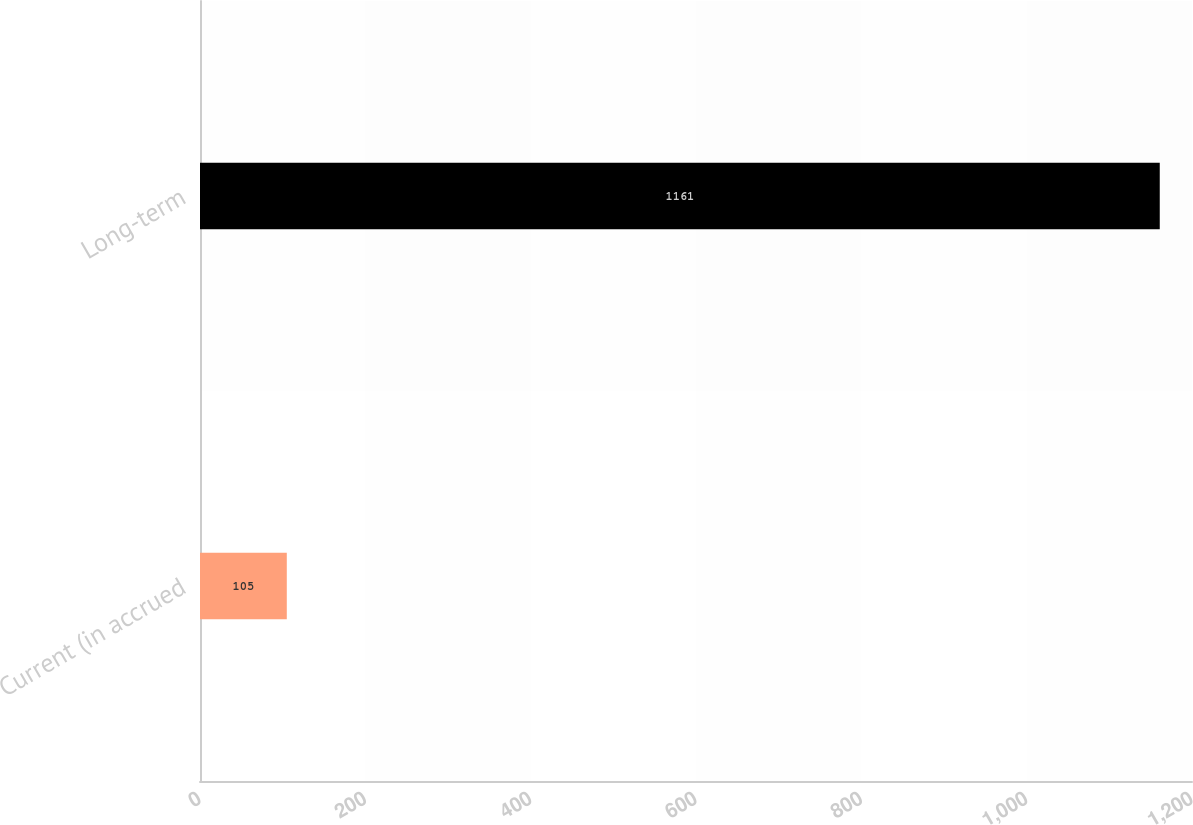Convert chart. <chart><loc_0><loc_0><loc_500><loc_500><bar_chart><fcel>Current (in accrued<fcel>Long-term<nl><fcel>105<fcel>1161<nl></chart> 